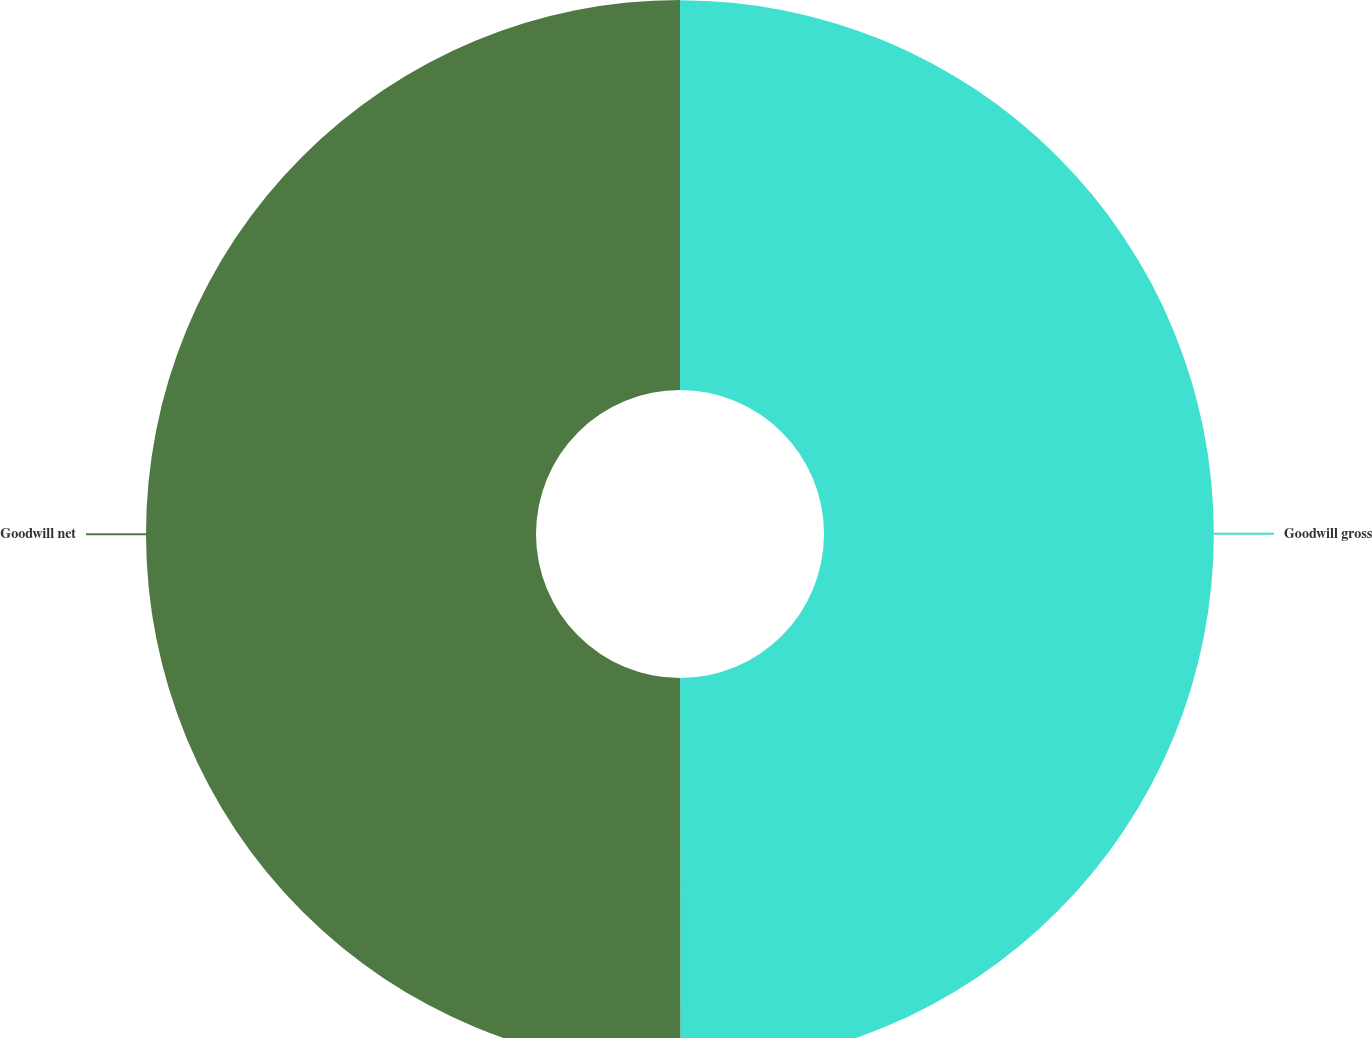<chart> <loc_0><loc_0><loc_500><loc_500><pie_chart><fcel>Goodwill gross<fcel>Goodwill net<nl><fcel>49.99%<fcel>50.01%<nl></chart> 